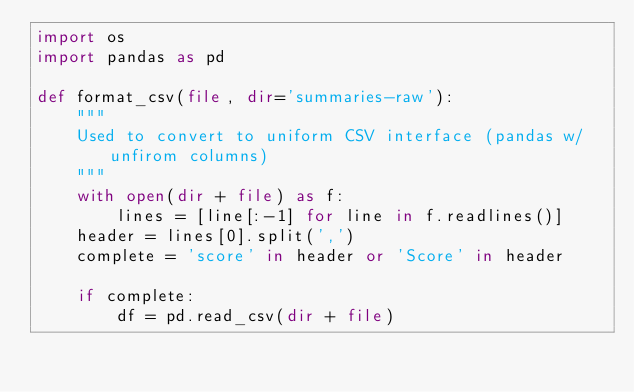<code> <loc_0><loc_0><loc_500><loc_500><_Python_>import os
import pandas as pd

def format_csv(file, dir='summaries-raw'):
    """
    Used to convert to uniform CSV interface (pandas w/ unfirom columns)
    """
    with open(dir + file) as f:
        lines = [line[:-1] for line in f.readlines()]
    header = lines[0].split(',')
    complete = 'score' in header or 'Score' in header

    if complete:
        df = pd.read_csv(dir + file)</code> 